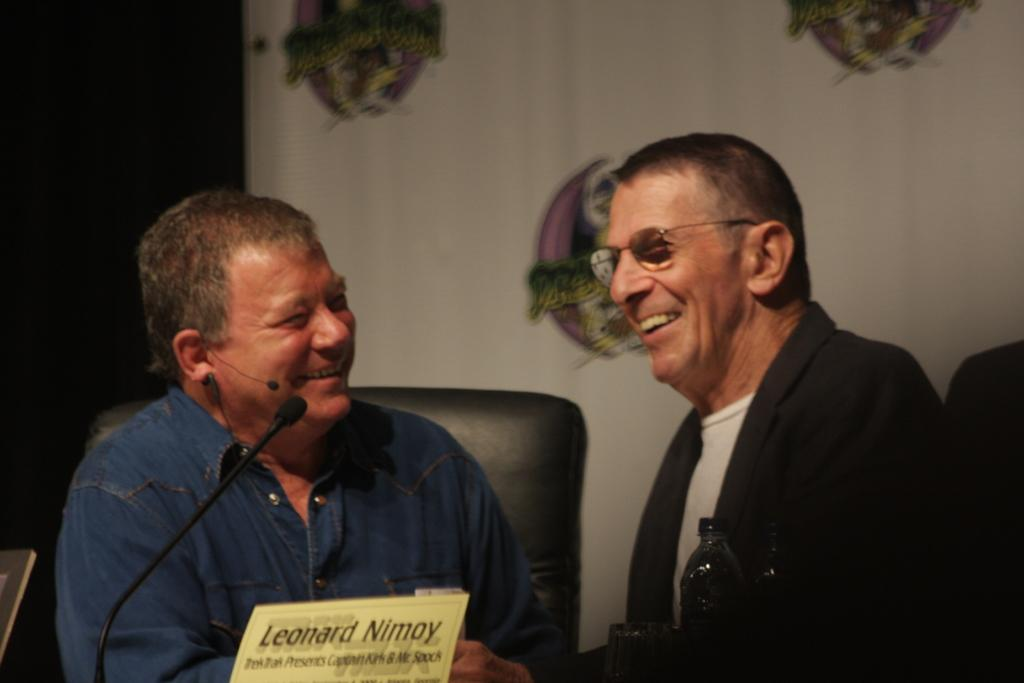How many people are in the image? There are two men in the image. What are the men doing in the image? The men are sitting on chairs and smiling. What objects can be seen in the image related to drinks? There is a bottle and a glass in the image. What object is typically used for amplifying sound? There is a mic in the image. What can be seen in the background of the image? There is a banner in the background of the image. Where are the toys stored in the image? There are no toys present in the image. What type of range is visible in the image? There is no range visible in the image. 